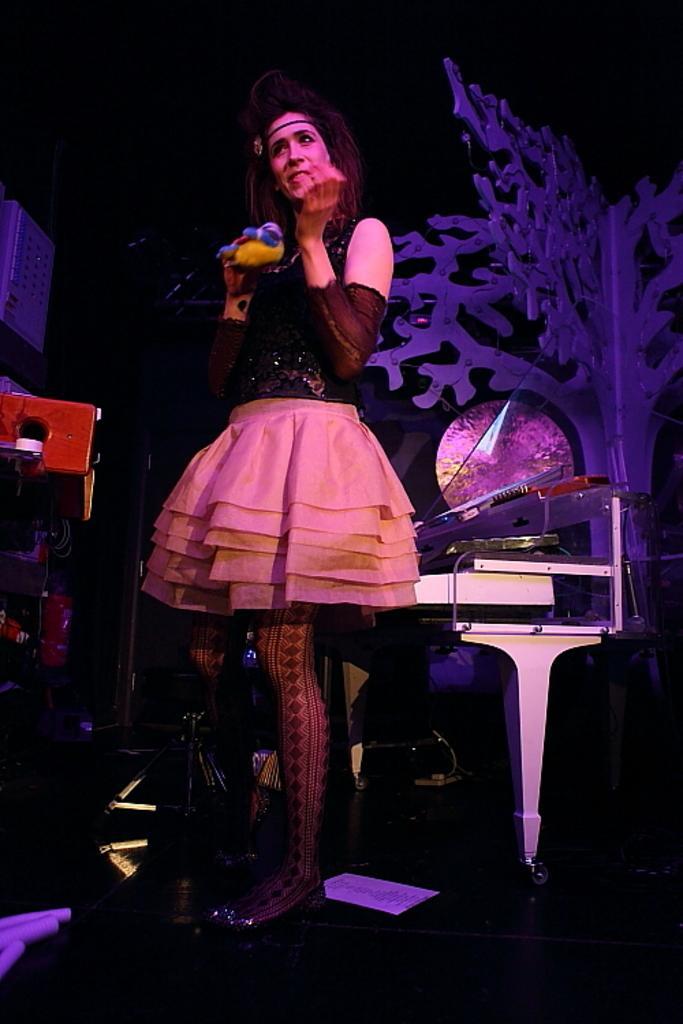Describe this image in one or two sentences. In this image there is a man standing, in the background there are musical instruments and there is an artificial tree. 